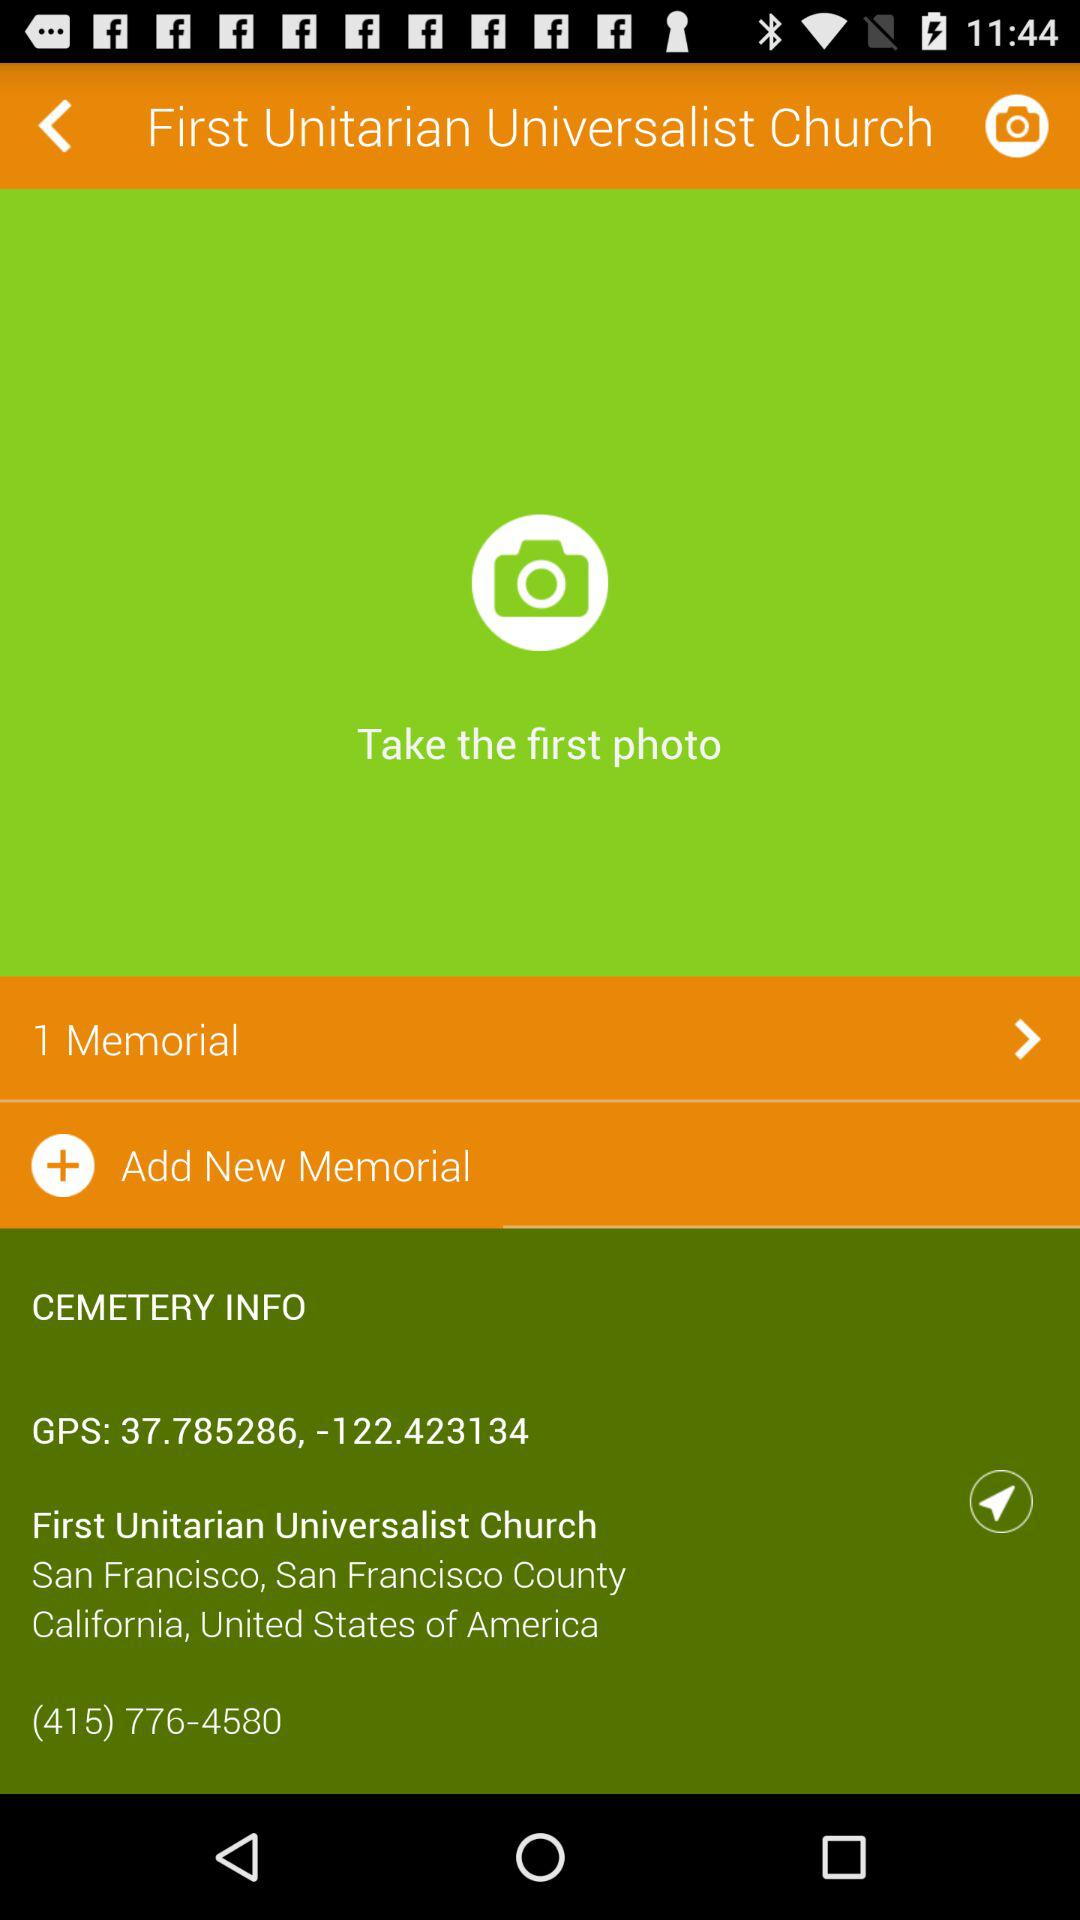What is the contact number of the first unitarian universalist church? The contact number is (415) 776-4580. 